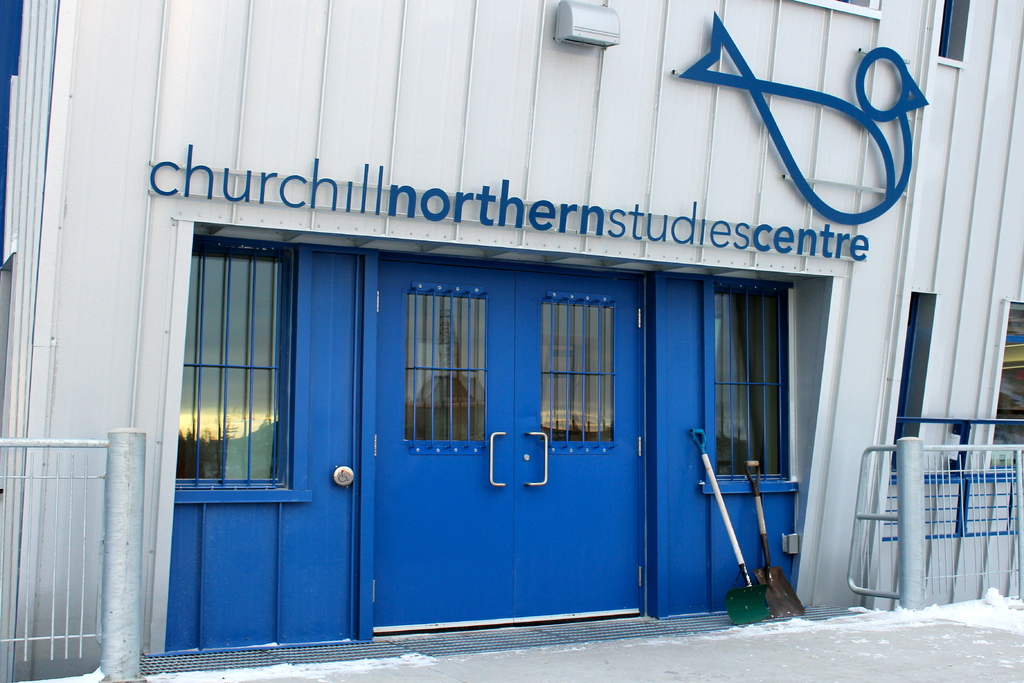Why might the shovel be an important tool for this facility? The shovel, propped beside the main entrance, is essential for maintaining clear and safe access to the facility during the snowy months. Given the location's sub-arctic climate, heavy snowfalls are common, and shoveling snow is a routine necessity to ensure the safety and mobility of researchers and staff at the centre. 